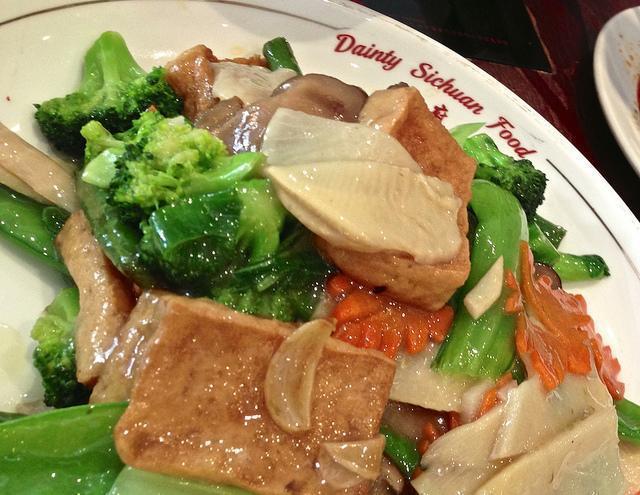How many carrots are there?
Give a very brief answer. 2. How many broccolis are in the picture?
Give a very brief answer. 6. 